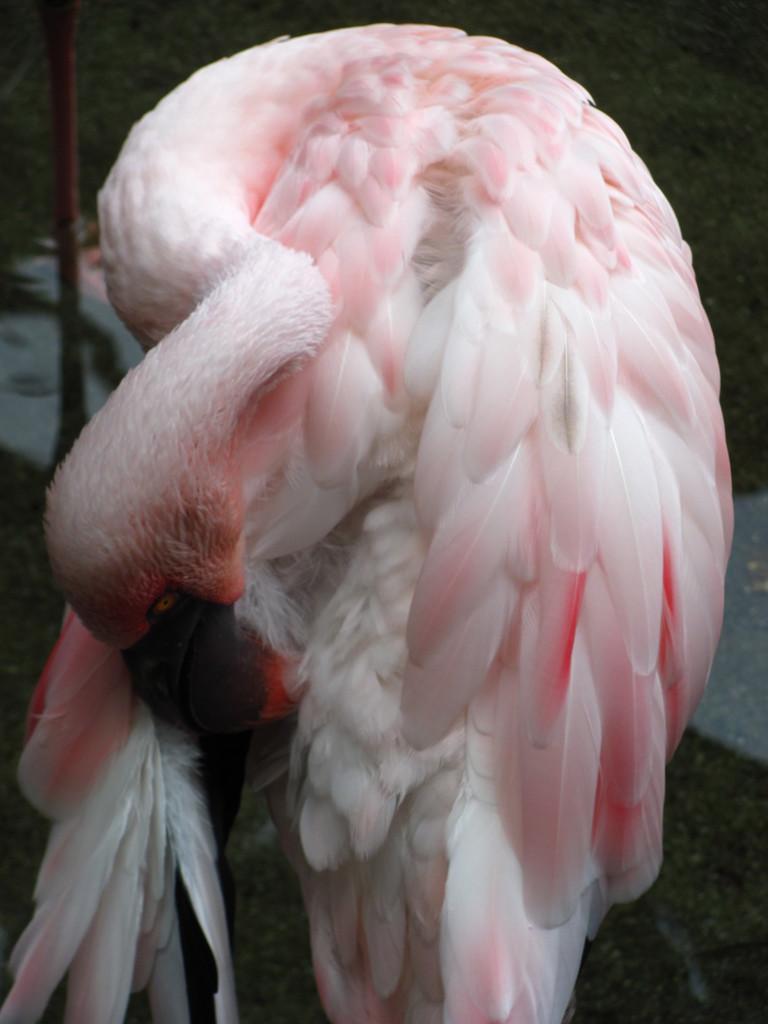Describe this image in one or two sentences. As we can see in the image in the front there is a white color bird and the background is dark. 